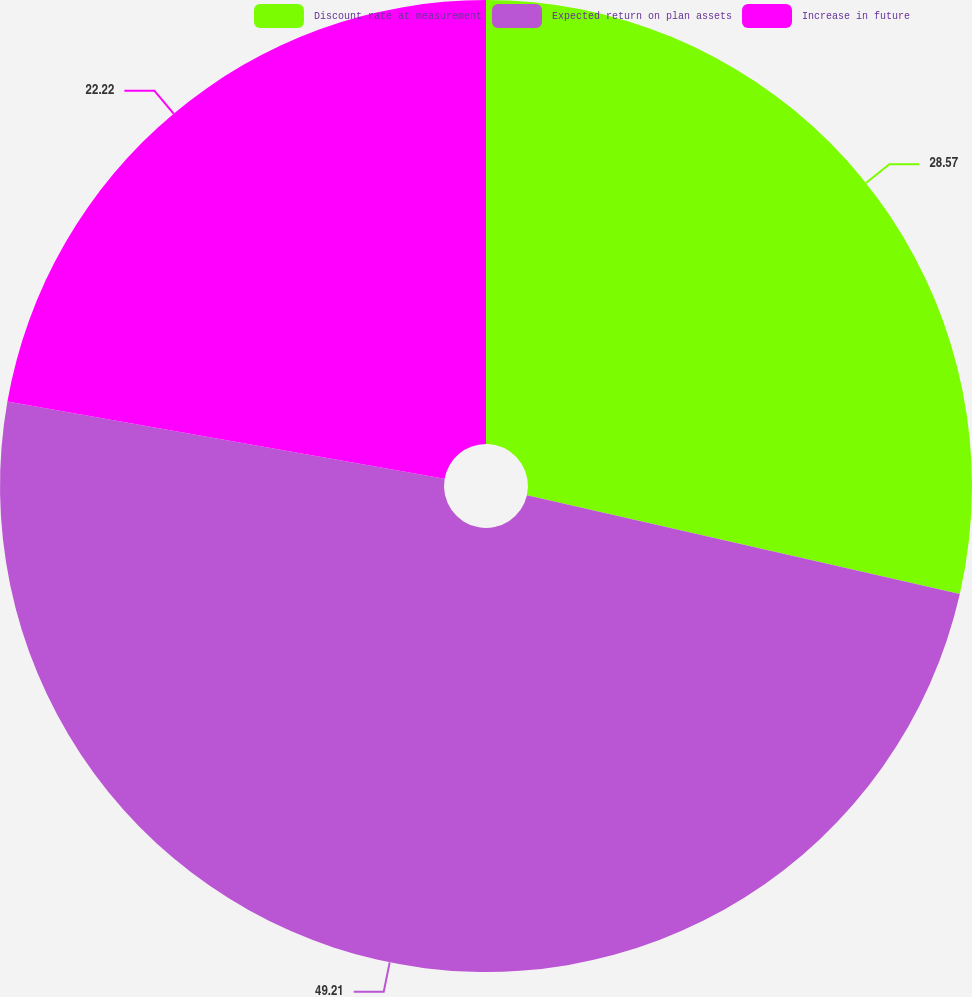<chart> <loc_0><loc_0><loc_500><loc_500><pie_chart><fcel>Discount rate at measurement<fcel>Expected return on plan assets<fcel>Increase in future<nl><fcel>28.57%<fcel>49.21%<fcel>22.22%<nl></chart> 